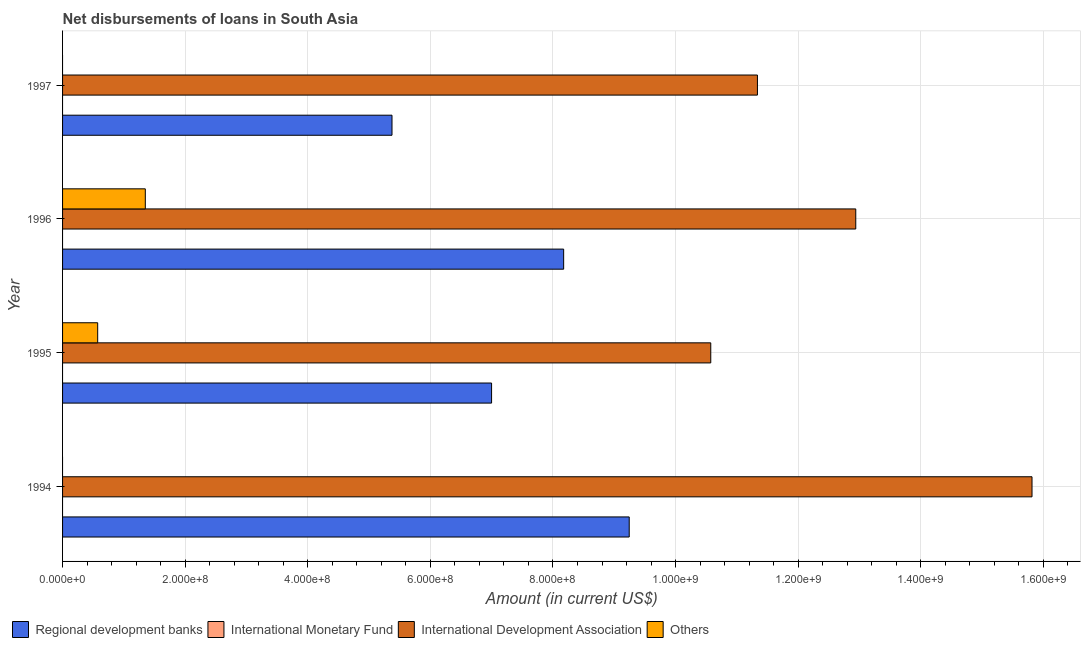How many different coloured bars are there?
Your response must be concise. 3. How many groups of bars are there?
Your response must be concise. 4. Are the number of bars on each tick of the Y-axis equal?
Offer a very short reply. No. How many bars are there on the 3rd tick from the top?
Provide a succinct answer. 3. How many bars are there on the 3rd tick from the bottom?
Offer a very short reply. 3. What is the label of the 3rd group of bars from the top?
Your answer should be very brief. 1995. In how many cases, is the number of bars for a given year not equal to the number of legend labels?
Your answer should be compact. 4. What is the amount of loan disimbursed by other organisations in 1996?
Provide a succinct answer. 1.35e+08. Across all years, what is the maximum amount of loan disimbursed by other organisations?
Provide a succinct answer. 1.35e+08. In which year was the amount of loan disimbursed by regional development banks maximum?
Ensure brevity in your answer.  1994. What is the total amount of loan disimbursed by international development association in the graph?
Offer a very short reply. 5.07e+09. What is the difference between the amount of loan disimbursed by international development association in 1994 and that in 1995?
Keep it short and to the point. 5.24e+08. What is the difference between the amount of loan disimbursed by international monetary fund in 1997 and the amount of loan disimbursed by other organisations in 1996?
Your response must be concise. -1.35e+08. In the year 1995, what is the difference between the amount of loan disimbursed by other organisations and amount of loan disimbursed by international development association?
Make the answer very short. -1.00e+09. In how many years, is the amount of loan disimbursed by other organisations greater than 600000000 US$?
Provide a succinct answer. 0. What is the ratio of the amount of loan disimbursed by regional development banks in 1996 to that in 1997?
Your answer should be compact. 1.52. What is the difference between the highest and the second highest amount of loan disimbursed by regional development banks?
Provide a succinct answer. 1.07e+08. What is the difference between the highest and the lowest amount of loan disimbursed by other organisations?
Your answer should be very brief. 1.35e+08. In how many years, is the amount of loan disimbursed by regional development banks greater than the average amount of loan disimbursed by regional development banks taken over all years?
Your answer should be very brief. 2. Is the sum of the amount of loan disimbursed by international development association in 1994 and 1997 greater than the maximum amount of loan disimbursed by regional development banks across all years?
Ensure brevity in your answer.  Yes. Is it the case that in every year, the sum of the amount of loan disimbursed by regional development banks and amount of loan disimbursed by international development association is greater than the sum of amount of loan disimbursed by international monetary fund and amount of loan disimbursed by other organisations?
Keep it short and to the point. Yes. Is it the case that in every year, the sum of the amount of loan disimbursed by regional development banks and amount of loan disimbursed by international monetary fund is greater than the amount of loan disimbursed by international development association?
Keep it short and to the point. No. How many years are there in the graph?
Offer a very short reply. 4. What is the difference between two consecutive major ticks on the X-axis?
Offer a very short reply. 2.00e+08. Does the graph contain any zero values?
Provide a short and direct response. Yes. How many legend labels are there?
Your answer should be compact. 4. What is the title of the graph?
Your answer should be compact. Net disbursements of loans in South Asia. What is the Amount (in current US$) of Regional development banks in 1994?
Offer a terse response. 9.24e+08. What is the Amount (in current US$) in International Development Association in 1994?
Offer a terse response. 1.58e+09. What is the Amount (in current US$) of Others in 1994?
Give a very brief answer. 0. What is the Amount (in current US$) in Regional development banks in 1995?
Provide a succinct answer. 7.00e+08. What is the Amount (in current US$) of International Development Association in 1995?
Ensure brevity in your answer.  1.06e+09. What is the Amount (in current US$) in Others in 1995?
Your answer should be compact. 5.73e+07. What is the Amount (in current US$) of Regional development banks in 1996?
Provide a succinct answer. 8.17e+08. What is the Amount (in current US$) in International Monetary Fund in 1996?
Your answer should be compact. 0. What is the Amount (in current US$) of International Development Association in 1996?
Make the answer very short. 1.29e+09. What is the Amount (in current US$) of Others in 1996?
Your response must be concise. 1.35e+08. What is the Amount (in current US$) in Regional development banks in 1997?
Your response must be concise. 5.37e+08. What is the Amount (in current US$) in International Monetary Fund in 1997?
Offer a terse response. 0. What is the Amount (in current US$) in International Development Association in 1997?
Your answer should be very brief. 1.13e+09. Across all years, what is the maximum Amount (in current US$) in Regional development banks?
Ensure brevity in your answer.  9.24e+08. Across all years, what is the maximum Amount (in current US$) in International Development Association?
Offer a very short reply. 1.58e+09. Across all years, what is the maximum Amount (in current US$) of Others?
Your response must be concise. 1.35e+08. Across all years, what is the minimum Amount (in current US$) in Regional development banks?
Your answer should be compact. 5.37e+08. Across all years, what is the minimum Amount (in current US$) of International Development Association?
Ensure brevity in your answer.  1.06e+09. What is the total Amount (in current US$) in Regional development banks in the graph?
Offer a very short reply. 2.98e+09. What is the total Amount (in current US$) of International Development Association in the graph?
Your answer should be compact. 5.07e+09. What is the total Amount (in current US$) in Others in the graph?
Your answer should be very brief. 1.92e+08. What is the difference between the Amount (in current US$) of Regional development banks in 1994 and that in 1995?
Make the answer very short. 2.25e+08. What is the difference between the Amount (in current US$) of International Development Association in 1994 and that in 1995?
Keep it short and to the point. 5.24e+08. What is the difference between the Amount (in current US$) of Regional development banks in 1994 and that in 1996?
Your response must be concise. 1.07e+08. What is the difference between the Amount (in current US$) of International Development Association in 1994 and that in 1996?
Provide a short and direct response. 2.88e+08. What is the difference between the Amount (in current US$) of Regional development banks in 1994 and that in 1997?
Your answer should be compact. 3.87e+08. What is the difference between the Amount (in current US$) in International Development Association in 1994 and that in 1997?
Your answer should be compact. 4.48e+08. What is the difference between the Amount (in current US$) in Regional development banks in 1995 and that in 1996?
Offer a terse response. -1.18e+08. What is the difference between the Amount (in current US$) in International Development Association in 1995 and that in 1996?
Keep it short and to the point. -2.37e+08. What is the difference between the Amount (in current US$) in Others in 1995 and that in 1996?
Your answer should be very brief. -7.77e+07. What is the difference between the Amount (in current US$) of Regional development banks in 1995 and that in 1997?
Give a very brief answer. 1.62e+08. What is the difference between the Amount (in current US$) in International Development Association in 1995 and that in 1997?
Ensure brevity in your answer.  -7.61e+07. What is the difference between the Amount (in current US$) of Regional development banks in 1996 and that in 1997?
Offer a very short reply. 2.80e+08. What is the difference between the Amount (in current US$) of International Development Association in 1996 and that in 1997?
Provide a succinct answer. 1.60e+08. What is the difference between the Amount (in current US$) of Regional development banks in 1994 and the Amount (in current US$) of International Development Association in 1995?
Keep it short and to the point. -1.33e+08. What is the difference between the Amount (in current US$) of Regional development banks in 1994 and the Amount (in current US$) of Others in 1995?
Keep it short and to the point. 8.67e+08. What is the difference between the Amount (in current US$) of International Development Association in 1994 and the Amount (in current US$) of Others in 1995?
Your answer should be compact. 1.52e+09. What is the difference between the Amount (in current US$) in Regional development banks in 1994 and the Amount (in current US$) in International Development Association in 1996?
Make the answer very short. -3.70e+08. What is the difference between the Amount (in current US$) of Regional development banks in 1994 and the Amount (in current US$) of Others in 1996?
Your answer should be compact. 7.89e+08. What is the difference between the Amount (in current US$) in International Development Association in 1994 and the Amount (in current US$) in Others in 1996?
Keep it short and to the point. 1.45e+09. What is the difference between the Amount (in current US$) in Regional development banks in 1994 and the Amount (in current US$) in International Development Association in 1997?
Provide a succinct answer. -2.09e+08. What is the difference between the Amount (in current US$) in Regional development banks in 1995 and the Amount (in current US$) in International Development Association in 1996?
Offer a very short reply. -5.94e+08. What is the difference between the Amount (in current US$) of Regional development banks in 1995 and the Amount (in current US$) of Others in 1996?
Your answer should be very brief. 5.65e+08. What is the difference between the Amount (in current US$) in International Development Association in 1995 and the Amount (in current US$) in Others in 1996?
Provide a succinct answer. 9.22e+08. What is the difference between the Amount (in current US$) in Regional development banks in 1995 and the Amount (in current US$) in International Development Association in 1997?
Your answer should be compact. -4.34e+08. What is the difference between the Amount (in current US$) in Regional development banks in 1996 and the Amount (in current US$) in International Development Association in 1997?
Your answer should be compact. -3.16e+08. What is the average Amount (in current US$) in Regional development banks per year?
Provide a short and direct response. 7.45e+08. What is the average Amount (in current US$) of International Monetary Fund per year?
Give a very brief answer. 0. What is the average Amount (in current US$) in International Development Association per year?
Offer a very short reply. 1.27e+09. What is the average Amount (in current US$) of Others per year?
Provide a succinct answer. 4.81e+07. In the year 1994, what is the difference between the Amount (in current US$) in Regional development banks and Amount (in current US$) in International Development Association?
Your answer should be compact. -6.57e+08. In the year 1995, what is the difference between the Amount (in current US$) of Regional development banks and Amount (in current US$) of International Development Association?
Ensure brevity in your answer.  -3.58e+08. In the year 1995, what is the difference between the Amount (in current US$) in Regional development banks and Amount (in current US$) in Others?
Your response must be concise. 6.43e+08. In the year 1995, what is the difference between the Amount (in current US$) of International Development Association and Amount (in current US$) of Others?
Ensure brevity in your answer.  1.00e+09. In the year 1996, what is the difference between the Amount (in current US$) of Regional development banks and Amount (in current US$) of International Development Association?
Your answer should be very brief. -4.77e+08. In the year 1996, what is the difference between the Amount (in current US$) of Regional development banks and Amount (in current US$) of Others?
Make the answer very short. 6.82e+08. In the year 1996, what is the difference between the Amount (in current US$) in International Development Association and Amount (in current US$) in Others?
Offer a terse response. 1.16e+09. In the year 1997, what is the difference between the Amount (in current US$) of Regional development banks and Amount (in current US$) of International Development Association?
Make the answer very short. -5.96e+08. What is the ratio of the Amount (in current US$) of Regional development banks in 1994 to that in 1995?
Make the answer very short. 1.32. What is the ratio of the Amount (in current US$) in International Development Association in 1994 to that in 1995?
Keep it short and to the point. 1.5. What is the ratio of the Amount (in current US$) of Regional development banks in 1994 to that in 1996?
Your answer should be compact. 1.13. What is the ratio of the Amount (in current US$) of International Development Association in 1994 to that in 1996?
Give a very brief answer. 1.22. What is the ratio of the Amount (in current US$) of Regional development banks in 1994 to that in 1997?
Give a very brief answer. 1.72. What is the ratio of the Amount (in current US$) of International Development Association in 1994 to that in 1997?
Your response must be concise. 1.4. What is the ratio of the Amount (in current US$) of Regional development banks in 1995 to that in 1996?
Your answer should be compact. 0.86. What is the ratio of the Amount (in current US$) of International Development Association in 1995 to that in 1996?
Your answer should be compact. 0.82. What is the ratio of the Amount (in current US$) of Others in 1995 to that in 1996?
Ensure brevity in your answer.  0.42. What is the ratio of the Amount (in current US$) of Regional development banks in 1995 to that in 1997?
Offer a terse response. 1.3. What is the ratio of the Amount (in current US$) in International Development Association in 1995 to that in 1997?
Provide a short and direct response. 0.93. What is the ratio of the Amount (in current US$) of Regional development banks in 1996 to that in 1997?
Keep it short and to the point. 1.52. What is the ratio of the Amount (in current US$) of International Development Association in 1996 to that in 1997?
Offer a very short reply. 1.14. What is the difference between the highest and the second highest Amount (in current US$) in Regional development banks?
Make the answer very short. 1.07e+08. What is the difference between the highest and the second highest Amount (in current US$) in International Development Association?
Your answer should be compact. 2.88e+08. What is the difference between the highest and the lowest Amount (in current US$) in Regional development banks?
Offer a very short reply. 3.87e+08. What is the difference between the highest and the lowest Amount (in current US$) in International Development Association?
Your answer should be very brief. 5.24e+08. What is the difference between the highest and the lowest Amount (in current US$) in Others?
Your response must be concise. 1.35e+08. 